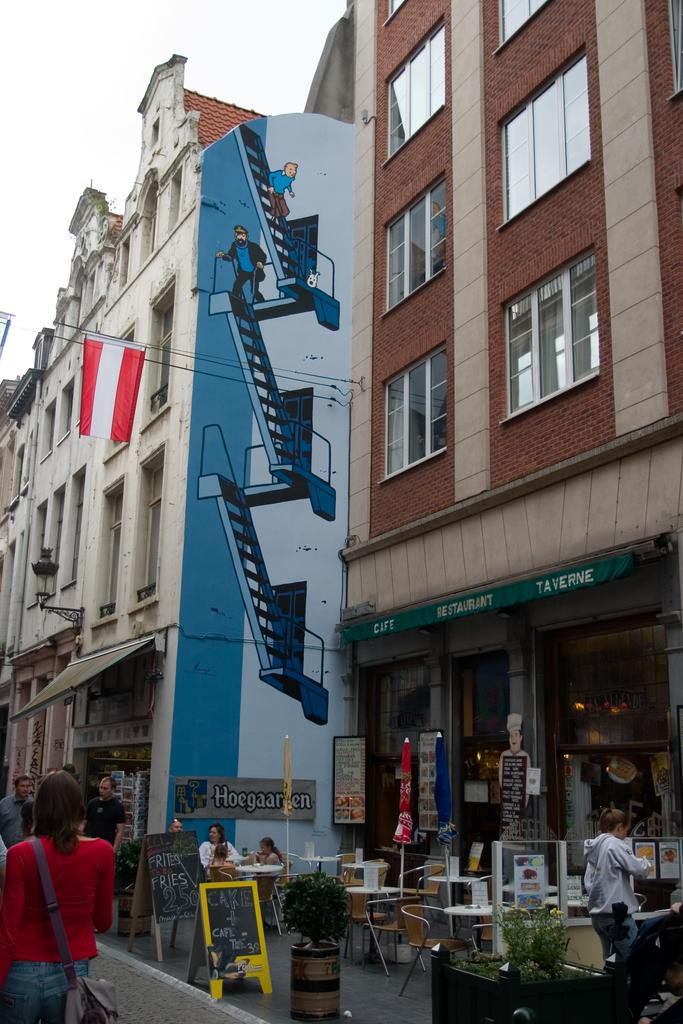What type of structures can be seen in the image? There are buildings in the image. What additional items are present in the image? There are banners, people, chairs, tables, and plants in the image. Can you describe any decorations or artwork in the image? There is a drawing on a building in the image. What is visible at the top of the image? The sky is visible at the top of the image. Can you see a dog playing with a pipe in the image? There is no dog or pipe present in the image. Is there any blood visible in the image? There is no blood visible in the image. 